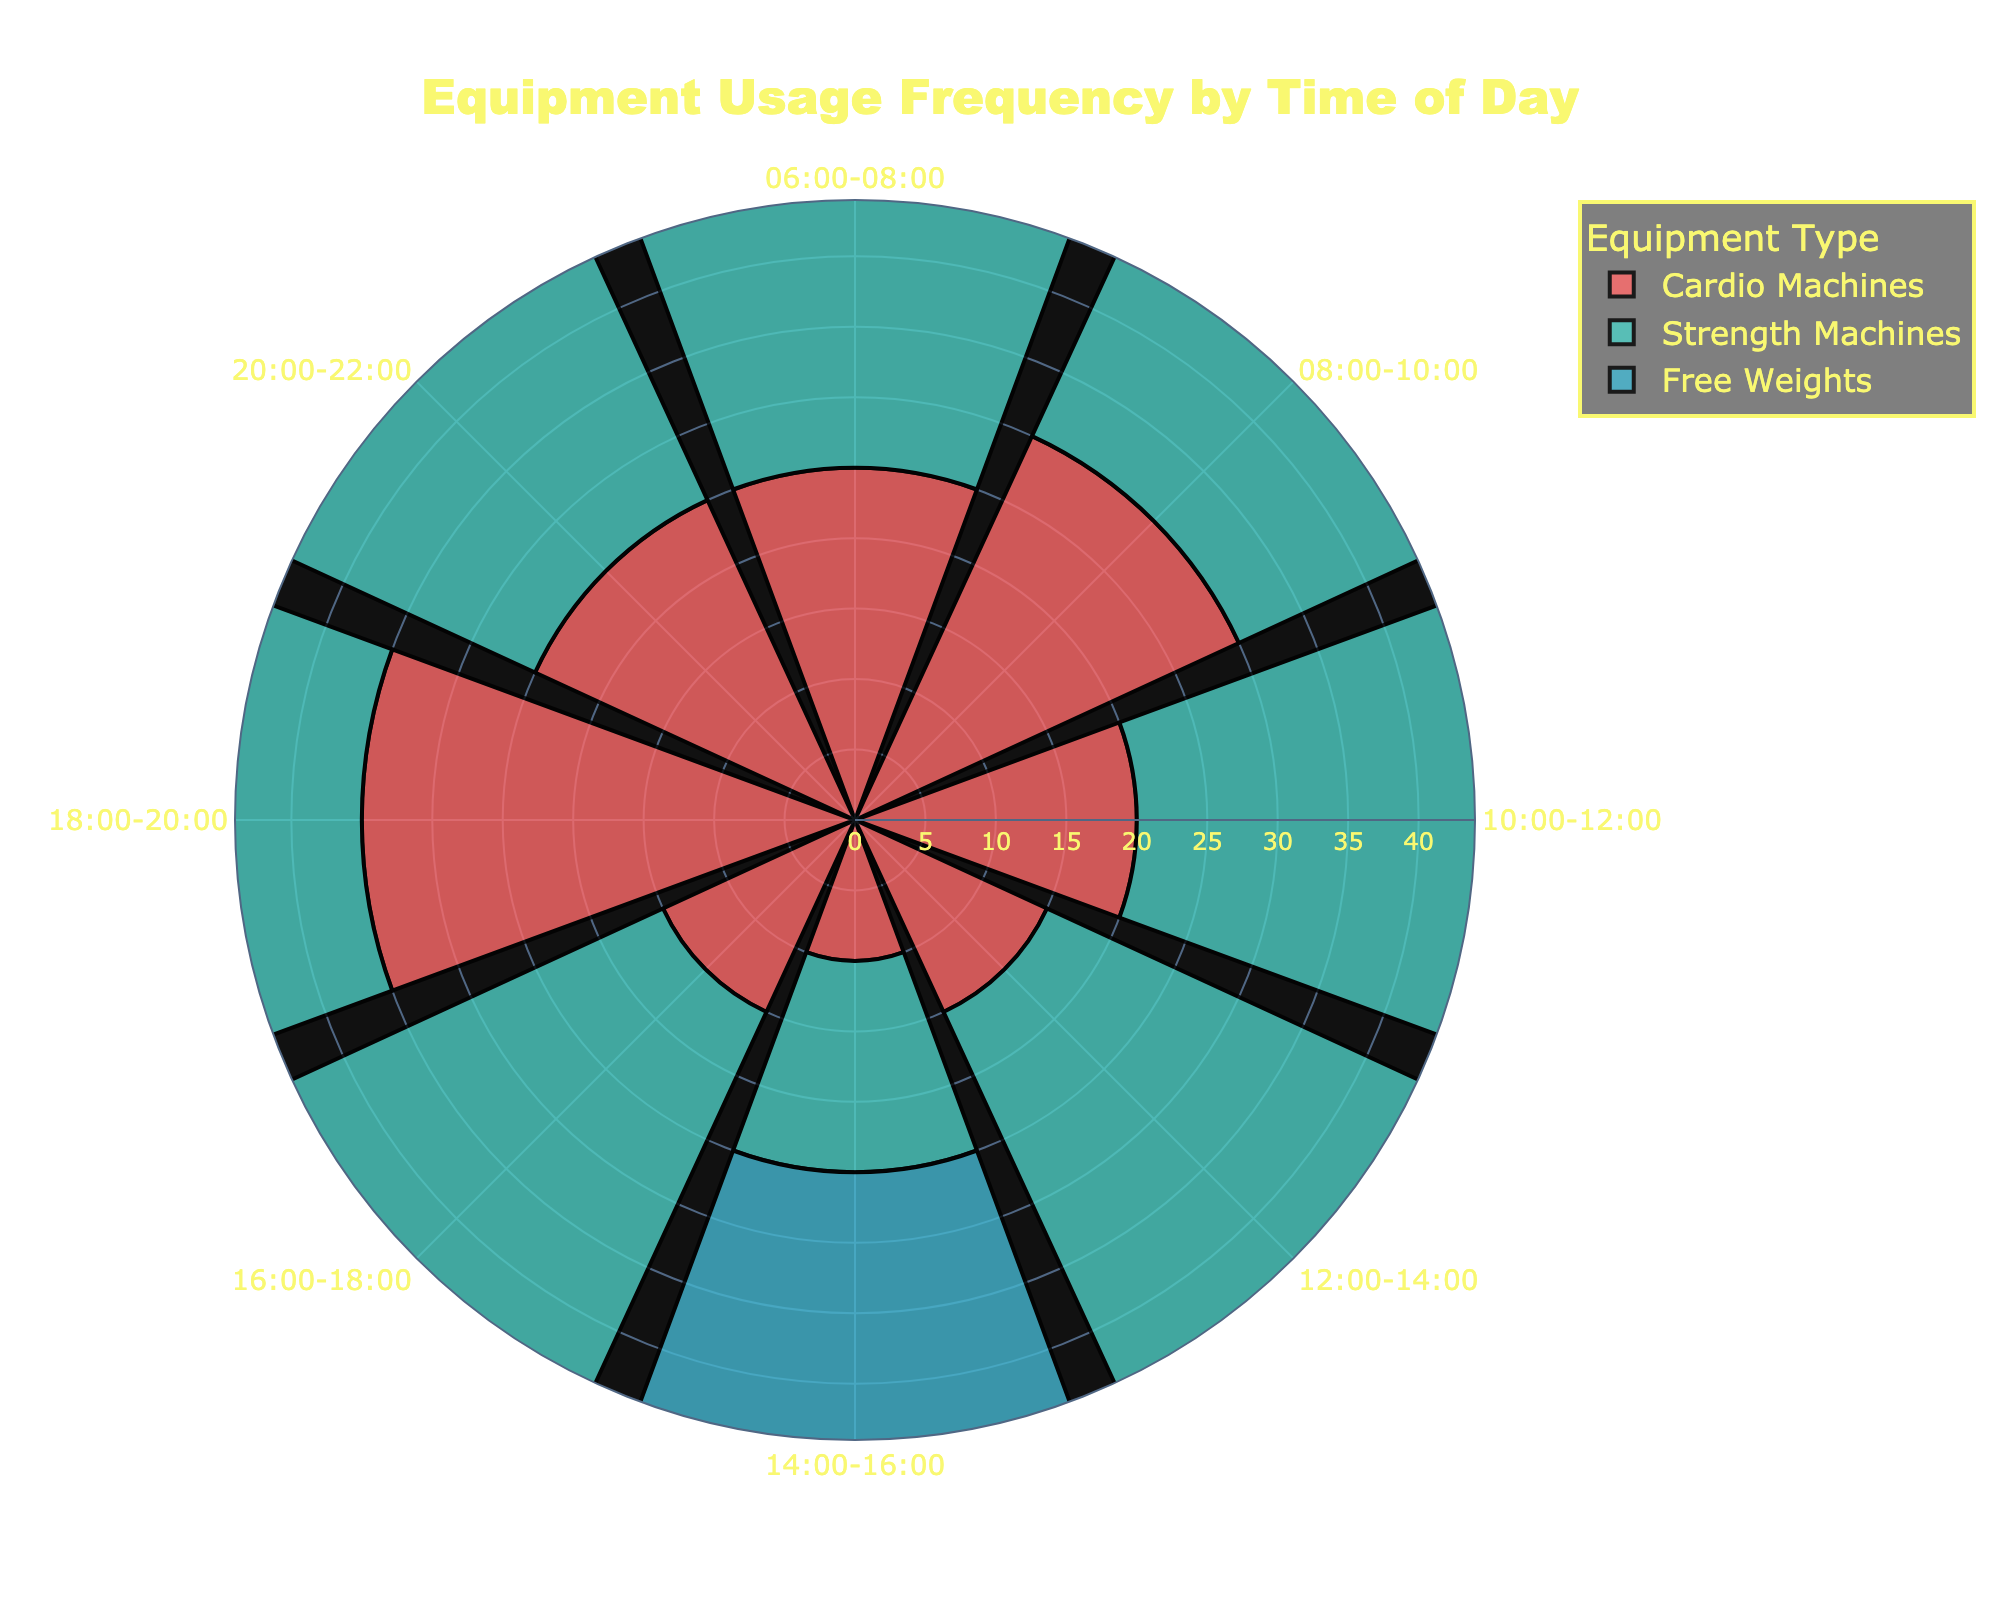what is the title of the figure? The title of the figure is usually prominent and located at the top. Here, the title given is "Equipment Usage Frequency by Time of Day".
Answer: Equipment Usage Frequency by Time of Day What color represents the Free Weights equipment? The color for each equipment type is generally indicated in the legend. For Free Weights equipment, it is marked with a distinct color. Upon inspection, the Free Weights is represented by a certain color in the chart.
Answer: #45B7D1 During which time period are Cardio Machines used the most? Look at the bars for Cardio Machines across different time periods and find the bar with the largest radius. The largest radius for Cardio Machines is during 18:00-20:00.
Answer: 18:00-20:00 What time period has the lowest combined usage of all equipment? Add up the usage frequencies of all three types of equipment for each time period, and find the smallest sum. For 14:00-16:00, the combined usage is 10 + 15 + 20 = 45, which is the lowest.
Answer: 14:00-16:00 Compare the usage of Strength Machines and Free Weights during 12:00-14:00. Which is used more? Check the lengths of the bars for Strength Machines and Free Weights during 12:00-14:00. Strength Machines have 30, while Free Weights have 35. Free Weights are used more.
Answer: Free Weights What time period has an equal usage frequency of Free Weights and Cardio Machines? Look for overlapping bar lengths for Free Weights and Cardio Machines across all time periods. Both have a usage frequency of 25 during 10:00-12:00.
Answer: 10:00-12:00 How does the usage frequency of Cardio Machines change from 06:00-08:00 to 08:00-10:00? Compare the bar lengths for Cardio Machines between the two periods. It increases from 25 to 30.
Answer: Increases What is the average usage of Free Weights throughout the day? Sum up the Free Weights usage for all periods and divide by the number of periods: (20 + 15 + 25 + 35 + 20 + 40 + 25 + 20) / 8 = 200 / 8
Answer: 25 Which equipment type shows the highest usage frequency during any time period? Compare the highest value for each equipment type across all periods. The highest value is 40 for Free Weights during 16:00-18:00.
Answer: Free Weights Between 18:00 and 20:00, which equipment type shows the most significant drop in usage during the next time period (20:00-22:00)? Compare the usage frequencies of each equipment type between these two consecutive periods: Cardio Machines drop from 35 to 25, Strength Machines from 40 to 20, and Free Weights from 25 to 20. Strength Machines drop by 20.
Answer: Strength Machines 